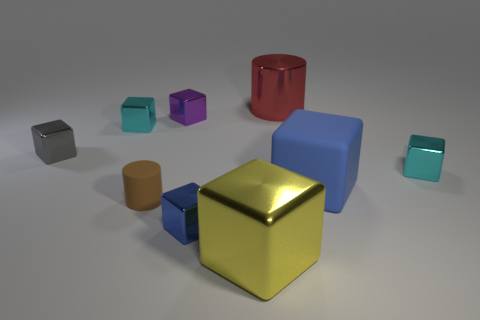There is a blue object in front of the small brown matte cylinder; what is it made of?
Give a very brief answer. Metal. Do the brown thing and the red metallic object have the same shape?
Give a very brief answer. Yes. There is a cylinder that is left of the tiny cube behind the tiny cyan object to the left of the brown thing; what color is it?
Your answer should be very brief. Brown. What number of brown matte things have the same shape as the large red metal thing?
Provide a succinct answer. 1. There is a cylinder that is behind the blue thing on the right side of the small blue block; what size is it?
Keep it short and to the point. Large. Do the gray thing and the red shiny object have the same size?
Offer a very short reply. No. Is there a blue metallic object right of the cyan metallic object to the right of the tiny brown rubber cylinder that is behind the big yellow metal thing?
Keep it short and to the point. No. What is the size of the red metal thing?
Provide a succinct answer. Large. How many gray metallic things have the same size as the purple thing?
Your answer should be compact. 1. There is a big yellow thing that is the same shape as the purple thing; what is it made of?
Give a very brief answer. Metal. 